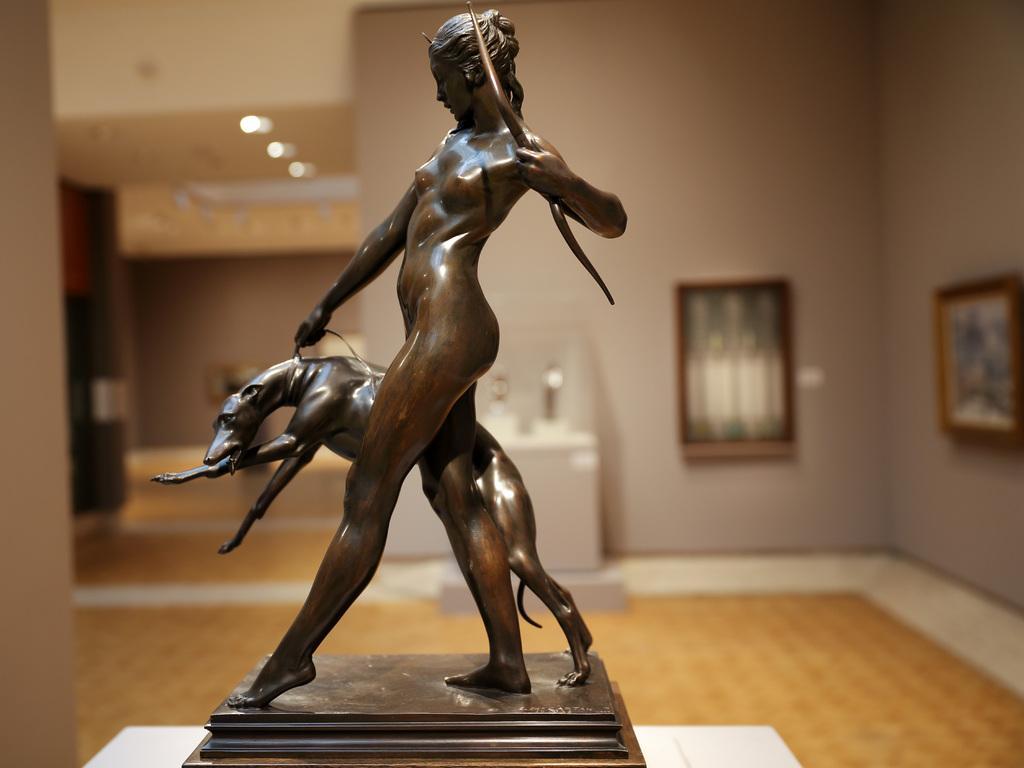How would you summarize this image in a sentence or two? In this image, we can see sculpture with stand on the white surface. Background there is a blur view. Here we can see wall, photo frames, floor, ceiling, lights and some objects. 